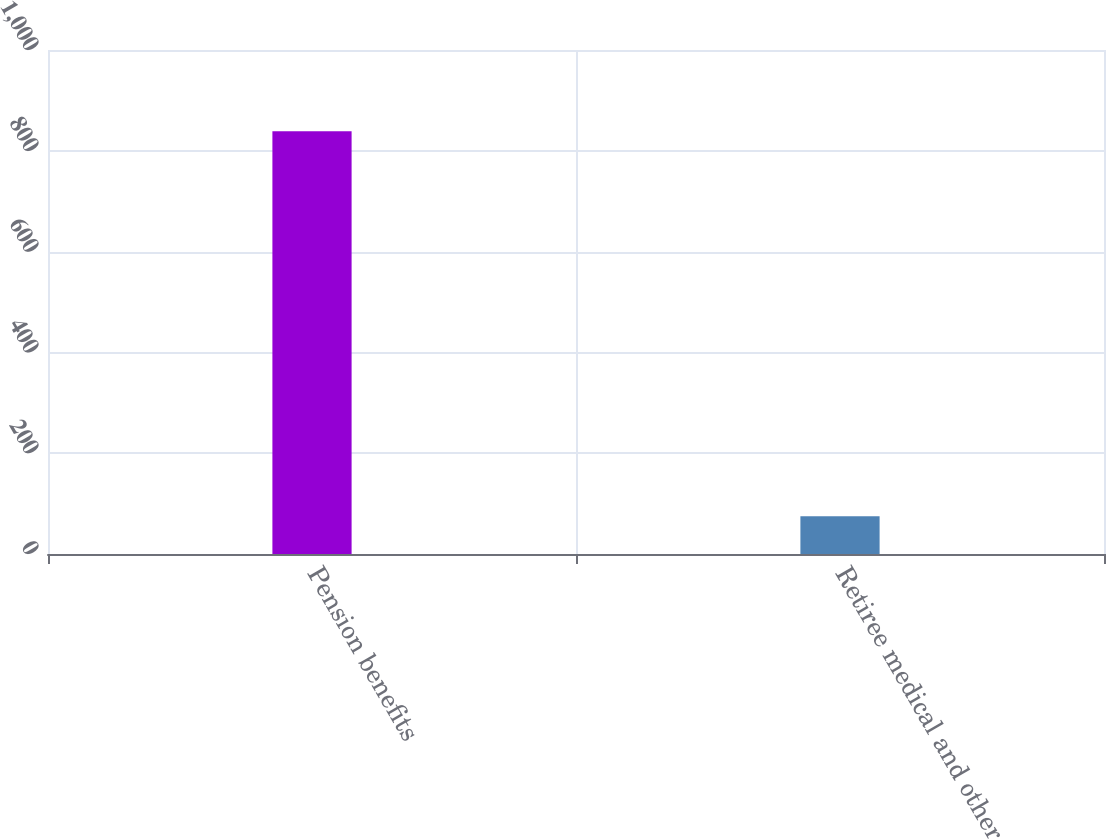Convert chart to OTSL. <chart><loc_0><loc_0><loc_500><loc_500><bar_chart><fcel>Pension benefits<fcel>Retiree medical and other<nl><fcel>839<fcel>75<nl></chart> 